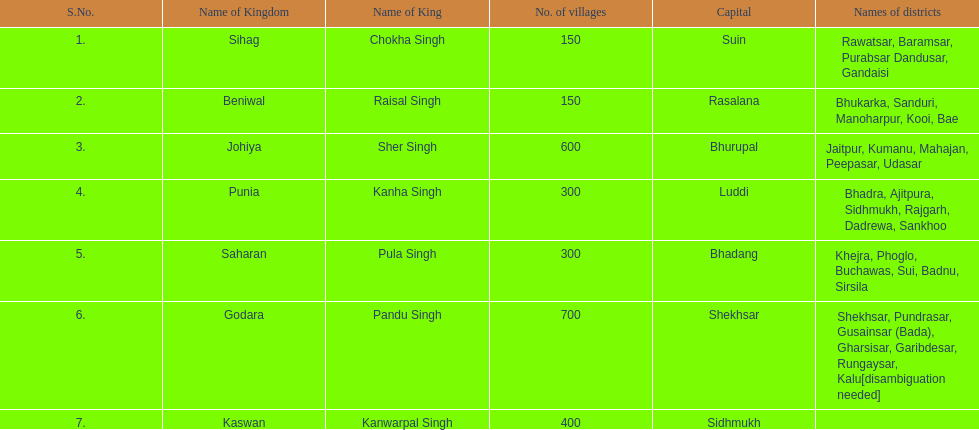In which kingdom can one find the highest number of villages? Godara. 